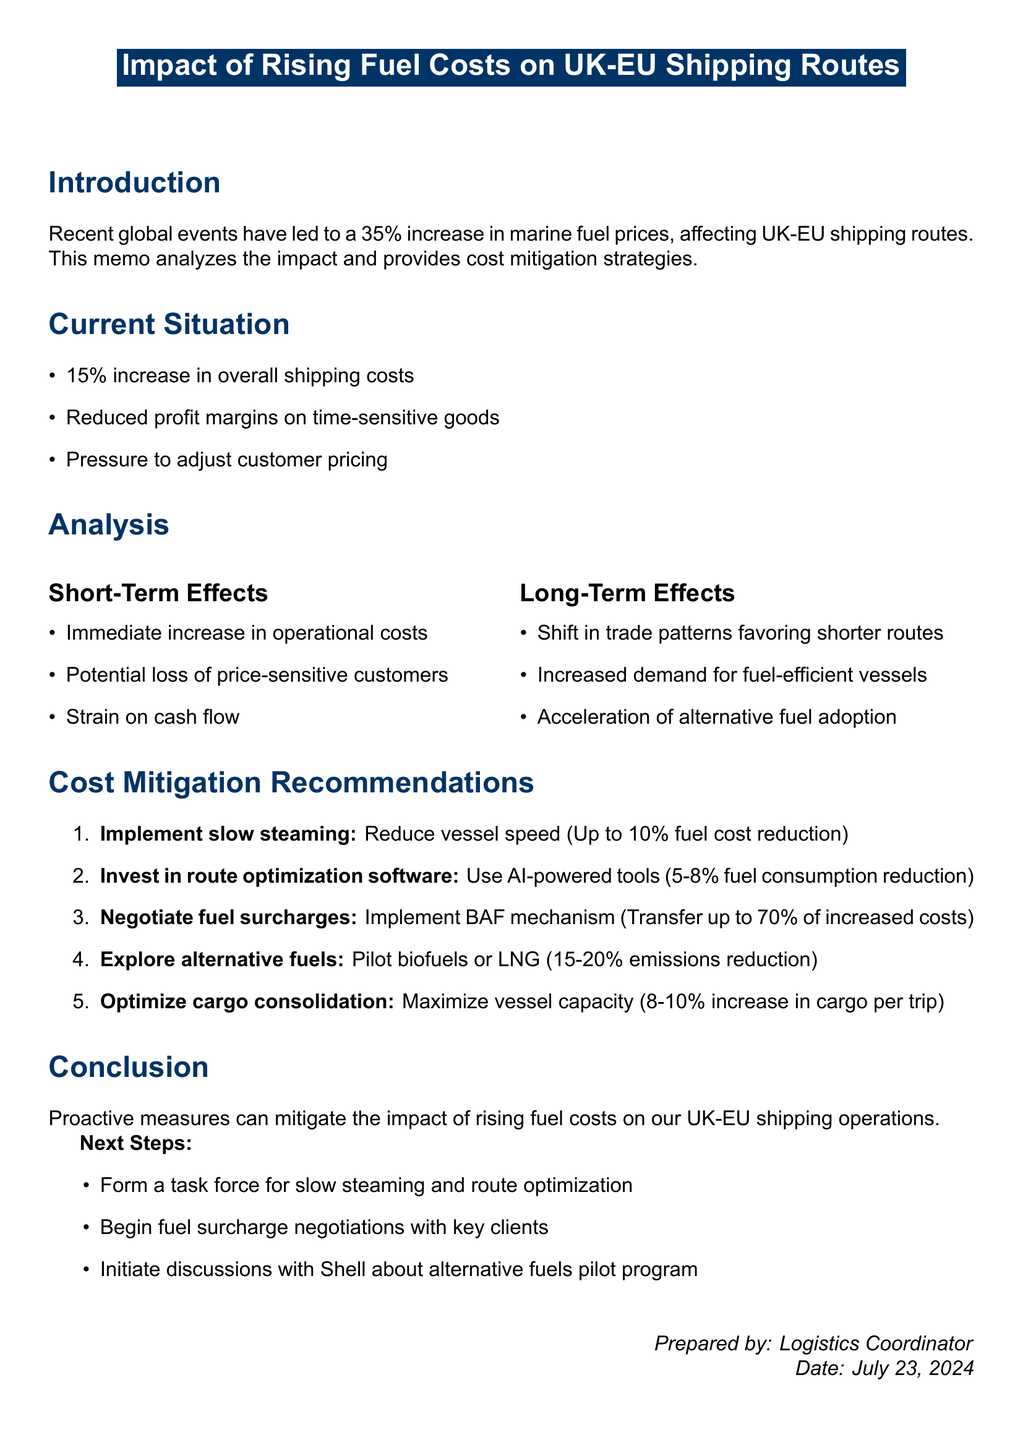What is the average increase in marine fuel prices? The document states that there has been an average increase of 35% in marine fuel prices over the past 6 months.
Answer: 35% Which routes are affected by rising fuel costs? The memo lists the affected routes as Dover-Calais, Felixstowe-Rotterdam, Hull-Zeebrugge, and Liverpool-Dublin.
Answer: Dover-Calais, Felixstowe-Rotterdam, Hull-Zeebrugge, Liverpool-Dublin What is one short-term effect of rising fuel costs? The document notes that one short-term effect is an immediate increase in operational costs.
Answer: Immediate increase in operational costs What potential savings can be achieved by implementing slow steaming? The recommendation for slow steaming mentions a potential savings of up to 10% reduction in fuel costs.
Answer: Up to 10% reduction in fuel costs What is the impact on overall shipping costs? The document states that there has been a 15% increase in overall shipping costs.
Answer: 15% increase in overall shipping costs Which company has reported a 12% increase in fuel-related costs? The memo refers to Maersk Line as the main competitor with a reported 12% increase in fuel-related costs.
Answer: Maersk Line How will the task force address the situation? The next steps include forming a task force to implement slow steaming and route optimization within the next month.
Answer: Form a task force What is one of the strategies to mitigate costs mentioned in the memo? The memo includes negotiating fuel surcharges with clients as one of the recommended strategies.
Answer: Negotiate fuel surcharges What percentage reduction in emissions is expected from exploring alternative fuels? The document indicates that exploring alternative fuels can lead to a 15-20% reduction in emissions.
Answer: 15-20% reduction in emissions 